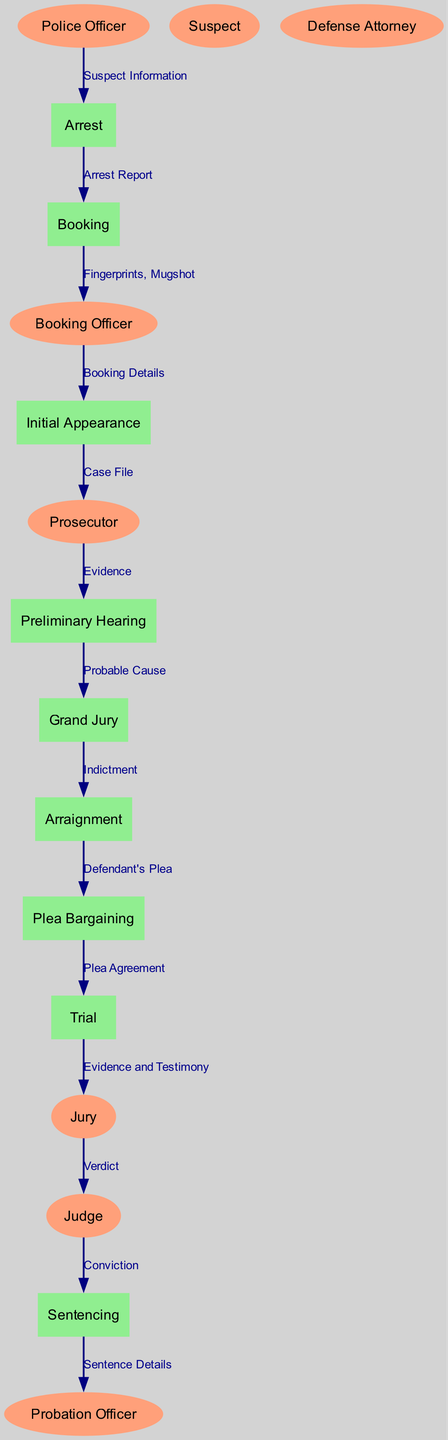What is the first process in the criminal case lifecycle? The diagram identifies "Arrest" as the first process, as it directly follows the information flow from the police officer to the initial action taken in a criminal case.
Answer: Arrest How many entities are there in the diagram? By counting the listed entities, there are a total of eight different roles highlighted in the diagram.
Answer: Eight What does the prosecutor pass to the preliminary hearing? The flow from the prosecutor to the preliminary hearing indicates they pass "Evidence," which is necessary for establishing probable cause.
Answer: Evidence What is the final step in the criminal case lifecycle? Following the logical flow through the diagram, the last process mentioned is "Sentencing," which concludes the lifecycle of a criminal case.
Answer: Sentencing Which process comes after "Arraignment"? The diagram indicates that "Plea Bargaining" follows "Arraignment," showing the sequence of processes in this lifecycle.
Answer: Plea Bargaining What information is given to the judge by the jury? The jury provides the "Verdict" to the judge, which is a crucial piece of information in determining the outcome of the trial.
Answer: Verdict How many data flows are present in the diagram? A careful count of the connections listed reveals there are thirteen data flows, each representing the movement of information between entities and processes.
Answer: Thirteen What does the booking officer transition to after booking? The booking officer sends "Booking Details" to the "Initial Appearance," indicating the flow of information in the judicial process.
Answer: Initial Appearance What does the probation officer receive at the end? At the conclusion of the sentencing process, the probation officer receives "Sentence Details," which are important for supervising the convicted individual.
Answer: Sentence Details 